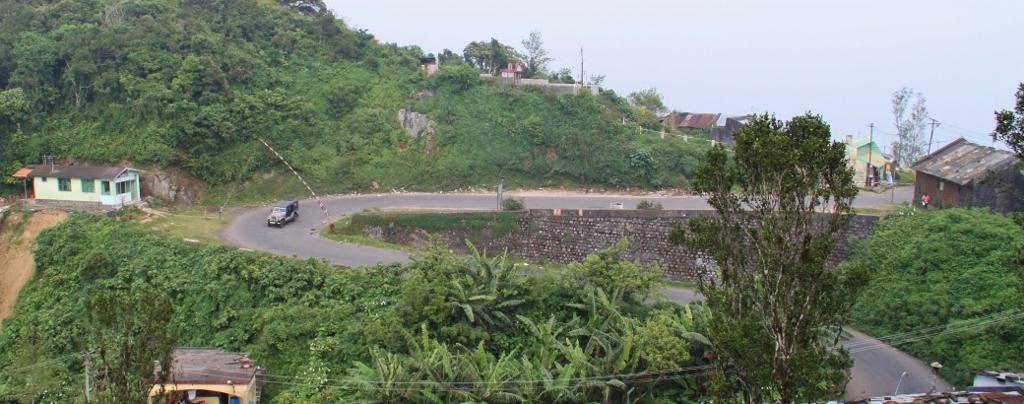What type of natural elements can be seen in the image? There are trees and hills visible in the image. What is happening on the road in the image? Vehicles are moving on the road in the image. What type of structures are present in the image? There are houses in the image. What else can be seen in the image besides the trees, vehicles, houses, and hills? Poles and wires are present in the image. What is visible in the background of the image? The sky is visible in the background of the image. What type of gold ornament is hanging from the wires in the image? There is no gold ornament present in the image; only poles and wires are visible. What type of meal is being prepared in the image? There is no meal being prepared in the image; the focus is on the trees, vehicles, houses, hills, poles, wires, and sky. 